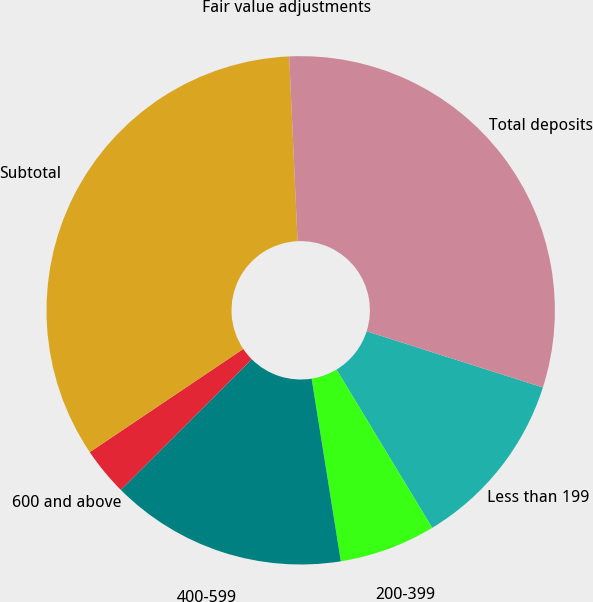Convert chart. <chart><loc_0><loc_0><loc_500><loc_500><pie_chart><fcel>Less than 199<fcel>200-399<fcel>400-599<fcel>600 and above<fcel>Subtotal<fcel>Fair value adjustments<fcel>Total deposits<nl><fcel>11.44%<fcel>6.13%<fcel>15.04%<fcel>3.06%<fcel>33.7%<fcel>0.0%<fcel>30.63%<nl></chart> 